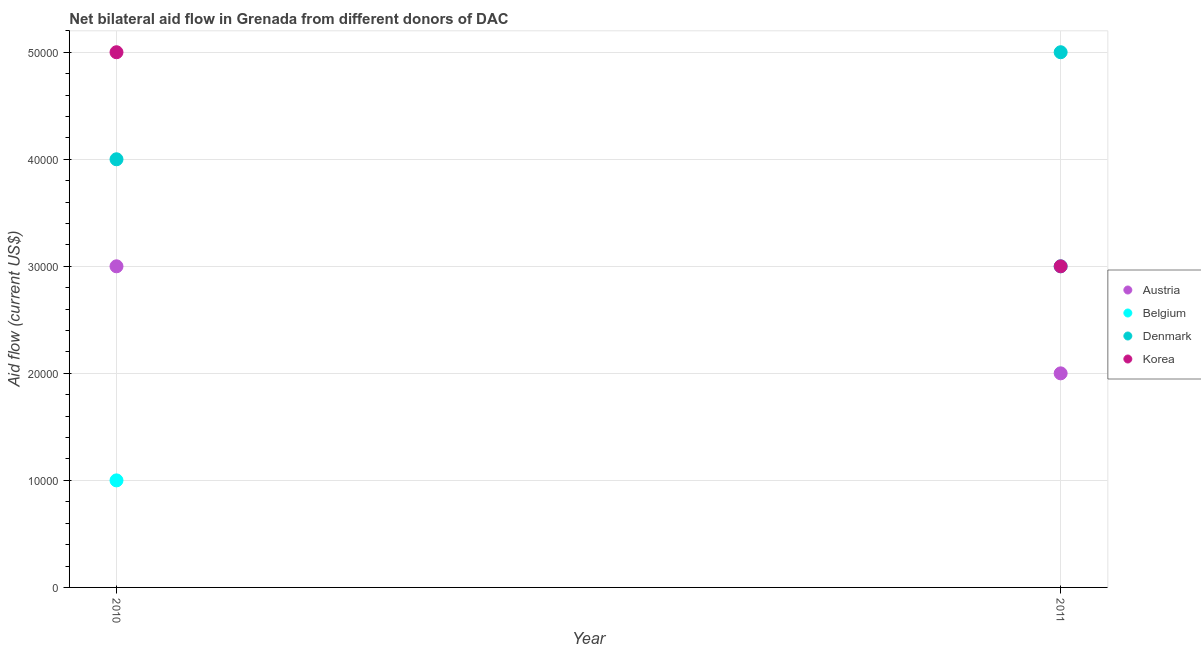Is the number of dotlines equal to the number of legend labels?
Give a very brief answer. Yes. What is the amount of aid given by korea in 2010?
Offer a terse response. 5.00e+04. Across all years, what is the maximum amount of aid given by korea?
Your response must be concise. 5.00e+04. Across all years, what is the minimum amount of aid given by belgium?
Provide a succinct answer. 10000. In which year was the amount of aid given by austria minimum?
Your answer should be very brief. 2011. What is the total amount of aid given by austria in the graph?
Ensure brevity in your answer.  5.00e+04. What is the difference between the amount of aid given by denmark in 2010 and that in 2011?
Offer a terse response. -10000. What is the difference between the amount of aid given by belgium in 2011 and the amount of aid given by korea in 2010?
Your answer should be very brief. -2.00e+04. In the year 2011, what is the difference between the amount of aid given by belgium and amount of aid given by korea?
Your answer should be very brief. 0. In how many years, is the amount of aid given by denmark greater than 28000 US$?
Offer a very short reply. 2. What is the ratio of the amount of aid given by belgium in 2010 to that in 2011?
Give a very brief answer. 0.33. Is the amount of aid given by denmark in 2010 less than that in 2011?
Provide a succinct answer. Yes. In how many years, is the amount of aid given by korea greater than the average amount of aid given by korea taken over all years?
Your answer should be compact. 1. Is it the case that in every year, the sum of the amount of aid given by austria and amount of aid given by korea is greater than the sum of amount of aid given by denmark and amount of aid given by belgium?
Your response must be concise. No. Does the amount of aid given by korea monotonically increase over the years?
Provide a short and direct response. No. Is the amount of aid given by austria strictly less than the amount of aid given by denmark over the years?
Make the answer very short. Yes. How many dotlines are there?
Make the answer very short. 4. How many years are there in the graph?
Offer a very short reply. 2. What is the difference between two consecutive major ticks on the Y-axis?
Make the answer very short. 10000. Does the graph contain grids?
Your response must be concise. Yes. Where does the legend appear in the graph?
Offer a terse response. Center right. How are the legend labels stacked?
Keep it short and to the point. Vertical. What is the title of the graph?
Provide a short and direct response. Net bilateral aid flow in Grenada from different donors of DAC. What is the label or title of the X-axis?
Your response must be concise. Year. What is the Aid flow (current US$) in Austria in 2010?
Your answer should be compact. 3.00e+04. What is the Aid flow (current US$) in Denmark in 2010?
Your answer should be compact. 4.00e+04. What is the Aid flow (current US$) in Korea in 2010?
Offer a terse response. 5.00e+04. What is the Aid flow (current US$) in Denmark in 2011?
Your answer should be very brief. 5.00e+04. Across all years, what is the maximum Aid flow (current US$) in Austria?
Your answer should be very brief. 3.00e+04. Across all years, what is the maximum Aid flow (current US$) of Denmark?
Your response must be concise. 5.00e+04. Across all years, what is the maximum Aid flow (current US$) in Korea?
Provide a succinct answer. 5.00e+04. Across all years, what is the minimum Aid flow (current US$) in Austria?
Offer a terse response. 2.00e+04. Across all years, what is the minimum Aid flow (current US$) of Belgium?
Ensure brevity in your answer.  10000. Across all years, what is the minimum Aid flow (current US$) in Denmark?
Your answer should be compact. 4.00e+04. What is the total Aid flow (current US$) in Belgium in the graph?
Provide a short and direct response. 4.00e+04. What is the total Aid flow (current US$) in Korea in the graph?
Your answer should be compact. 8.00e+04. What is the difference between the Aid flow (current US$) of Belgium in 2010 and that in 2011?
Keep it short and to the point. -2.00e+04. What is the difference between the Aid flow (current US$) in Korea in 2010 and that in 2011?
Provide a short and direct response. 2.00e+04. What is the difference between the Aid flow (current US$) in Austria in 2010 and the Aid flow (current US$) in Denmark in 2011?
Keep it short and to the point. -2.00e+04. What is the difference between the Aid flow (current US$) in Austria in 2010 and the Aid flow (current US$) in Korea in 2011?
Offer a terse response. 0. What is the difference between the Aid flow (current US$) of Belgium in 2010 and the Aid flow (current US$) of Korea in 2011?
Your response must be concise. -2.00e+04. What is the difference between the Aid flow (current US$) of Denmark in 2010 and the Aid flow (current US$) of Korea in 2011?
Ensure brevity in your answer.  10000. What is the average Aid flow (current US$) in Austria per year?
Provide a succinct answer. 2.50e+04. What is the average Aid flow (current US$) of Belgium per year?
Give a very brief answer. 2.00e+04. What is the average Aid flow (current US$) of Denmark per year?
Provide a short and direct response. 4.50e+04. In the year 2010, what is the difference between the Aid flow (current US$) of Austria and Aid flow (current US$) of Denmark?
Your response must be concise. -10000. In the year 2010, what is the difference between the Aid flow (current US$) in Austria and Aid flow (current US$) in Korea?
Your answer should be compact. -2.00e+04. In the year 2010, what is the difference between the Aid flow (current US$) of Belgium and Aid flow (current US$) of Denmark?
Your response must be concise. -3.00e+04. In the year 2010, what is the difference between the Aid flow (current US$) of Belgium and Aid flow (current US$) of Korea?
Offer a terse response. -4.00e+04. In the year 2010, what is the difference between the Aid flow (current US$) of Denmark and Aid flow (current US$) of Korea?
Your answer should be very brief. -10000. In the year 2011, what is the difference between the Aid flow (current US$) of Austria and Aid flow (current US$) of Belgium?
Provide a succinct answer. -10000. In the year 2011, what is the difference between the Aid flow (current US$) in Austria and Aid flow (current US$) in Korea?
Offer a terse response. -10000. In the year 2011, what is the difference between the Aid flow (current US$) in Belgium and Aid flow (current US$) in Denmark?
Your response must be concise. -2.00e+04. What is the ratio of the Aid flow (current US$) of Austria in 2010 to that in 2011?
Give a very brief answer. 1.5. What is the ratio of the Aid flow (current US$) in Belgium in 2010 to that in 2011?
Keep it short and to the point. 0.33. What is the ratio of the Aid flow (current US$) in Korea in 2010 to that in 2011?
Offer a very short reply. 1.67. What is the difference between the highest and the second highest Aid flow (current US$) in Austria?
Make the answer very short. 10000. What is the difference between the highest and the second highest Aid flow (current US$) of Belgium?
Give a very brief answer. 2.00e+04. What is the difference between the highest and the second highest Aid flow (current US$) of Denmark?
Offer a terse response. 10000. What is the difference between the highest and the lowest Aid flow (current US$) of Austria?
Provide a succinct answer. 10000. What is the difference between the highest and the lowest Aid flow (current US$) of Belgium?
Give a very brief answer. 2.00e+04. What is the difference between the highest and the lowest Aid flow (current US$) in Denmark?
Keep it short and to the point. 10000. 